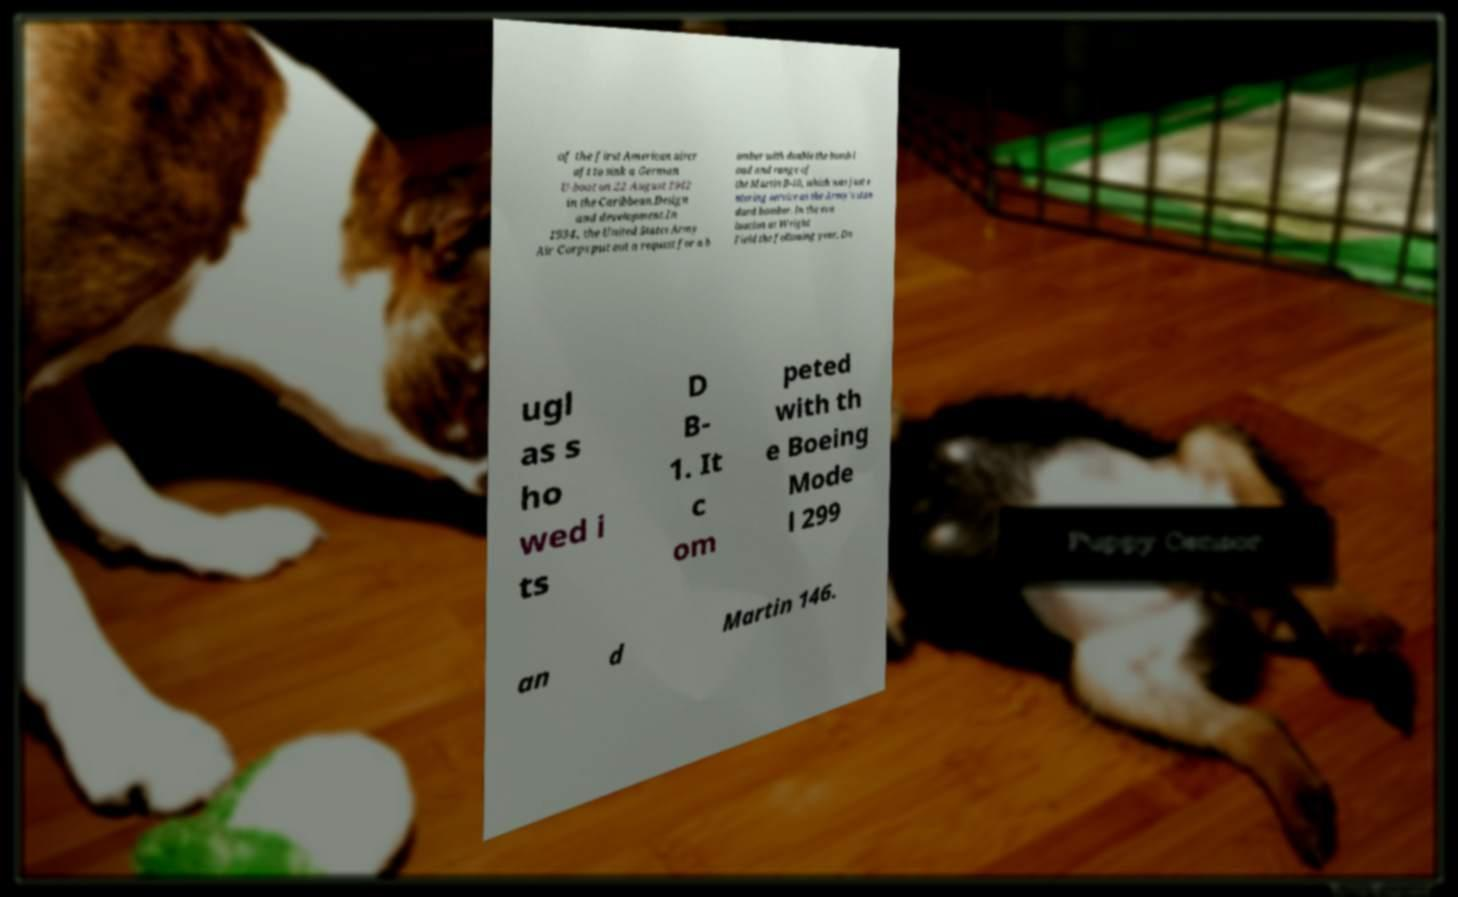Can you read and provide the text displayed in the image?This photo seems to have some interesting text. Can you extract and type it out for me? of the first American aircr aft to sink a German U-boat on 22 August 1942 in the Caribbean.Design and development.In 1934, the United States Army Air Corps put out a request for a b omber with double the bomb l oad and range of the Martin B-10, which was just e ntering service as the Army's stan dard bomber. In the eva luation at Wright Field the following year, Do ugl as s ho wed i ts D B- 1. It c om peted with th e Boeing Mode l 299 an d Martin 146. 